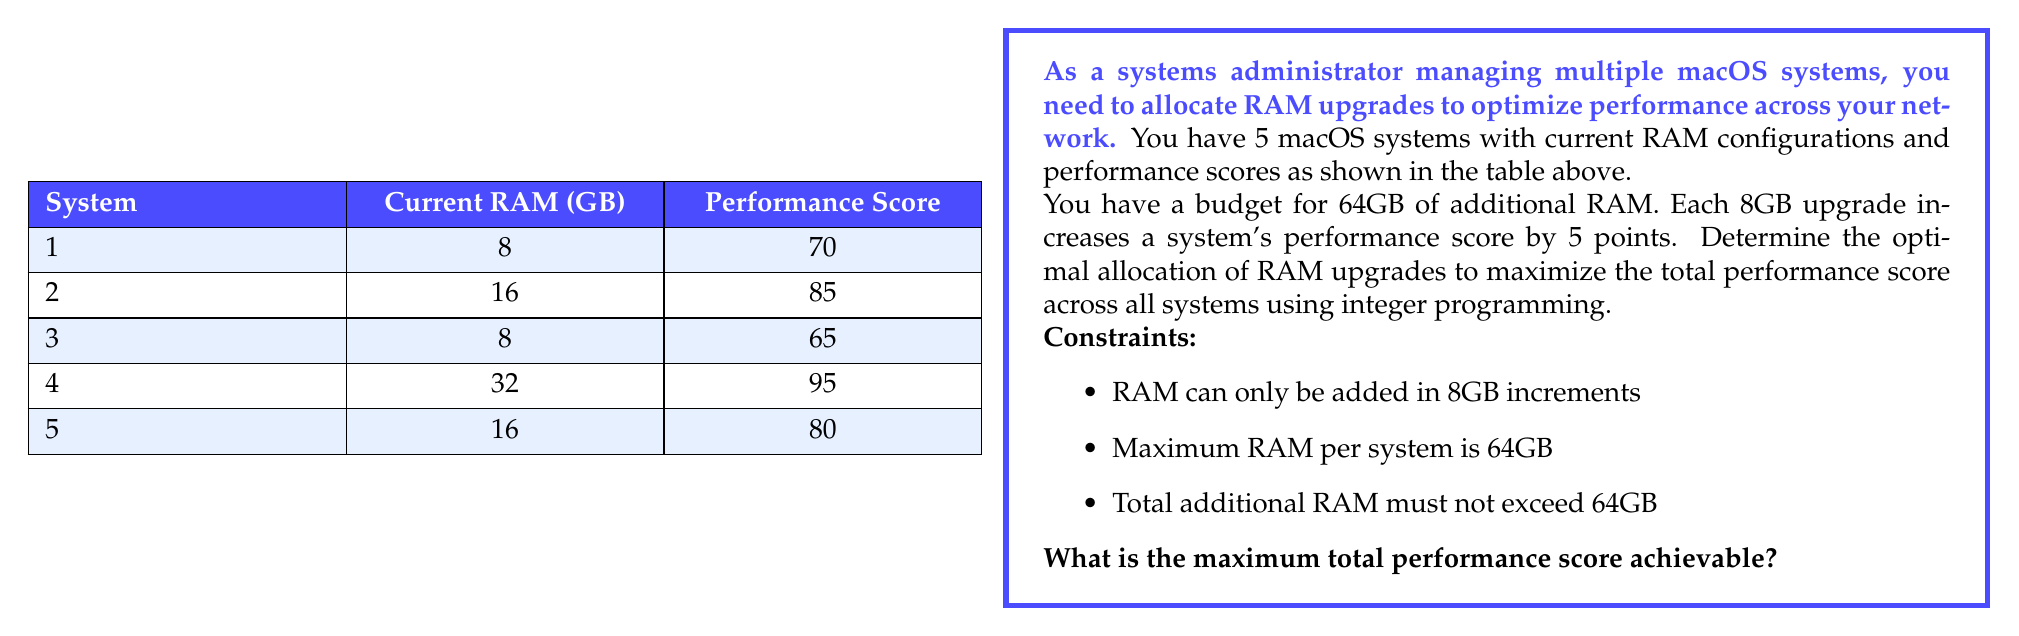Give your solution to this math problem. To solve this problem using integer programming, we'll follow these steps:

1) Define variables:
   Let $x_i$ be the number of 8GB RAM upgrades for system $i$ (where $i = 1, 2, 3, 4, 5$)

2) Objective function:
   Maximize total performance score:
   $$Z = (70 + 5x_1) + (85 + 5x_2) + (65 + 5x_3) + (95 + 5x_4) + (80 + 5x_5)$$

3) Constraints:
   a) Total RAM constraint: $8x_1 + 8x_2 + 8x_3 + 8x_4 + 8x_5 \leq 64$
   b) Maximum RAM per system constraints:
      $8 + 8x_1 \leq 64$, $16 + 8x_2 \leq 64$, $8 + 8x_3 \leq 64$, $32 + 8x_4 \leq 64$, $16 + 8x_5 \leq 64$
   c) Non-negativity and integer constraints: $x_i \geq 0$ and integer for all $i$

4) Simplify the constraints:
   a) $x_1 + x_2 + x_3 + x_4 + x_5 \leq 8$
   b) $x_1 \leq 7$, $x_2 \leq 6$, $x_3 \leq 7$, $x_4 \leq 4$, $x_5 \leq 6$

5) Solve the integer programming problem:
   The optimal solution is:
   $x_1 = 3$, $x_2 = 0$, $x_3 = 4$, $x_4 = 0$, $x_5 = 1$

6) Calculate the final performance scores:
   System 1: 70 + 5(3) = 85
   System 2: 85 + 5(0) = 85
   System 3: 65 + 5(4) = 85
   System 4: 95 + 5(0) = 95
   System 5: 80 + 5(1) = 85

7) Sum the final performance scores:
   85 + 85 + 85 + 95 + 85 = 435

Therefore, the maximum total performance score achievable is 435.
Answer: 435 